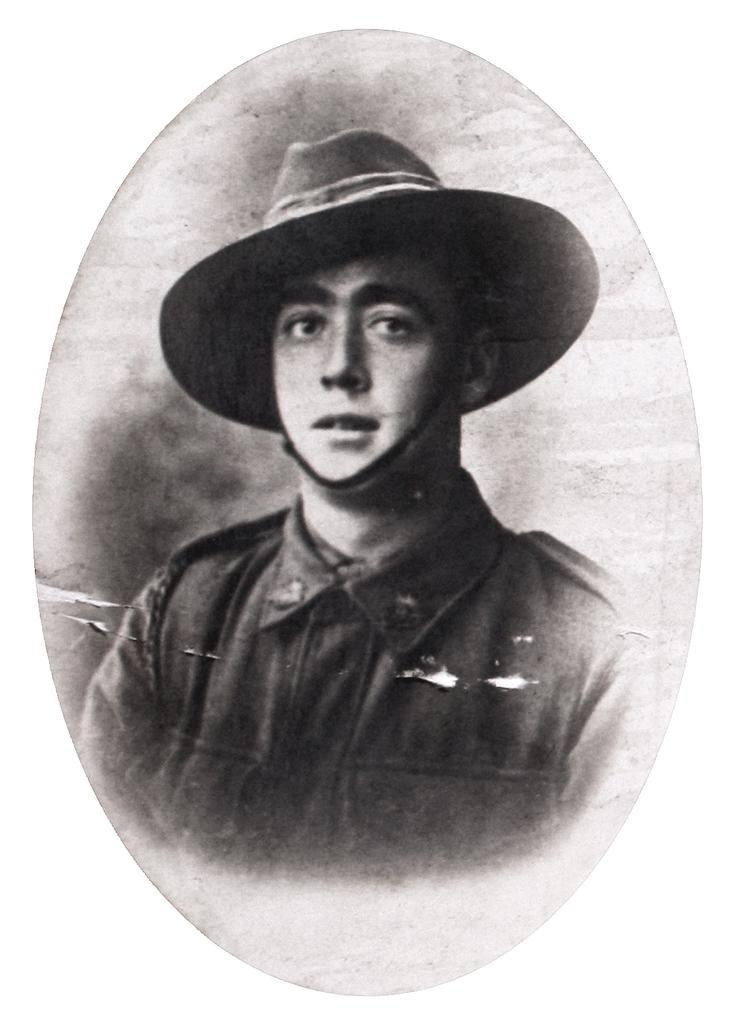What is the main subject of the image? There is a person in the image. What is the person wearing on their head? The person is wearing a hat. What is the color scheme of the image? The image is in black and white. What type of soup is being served in the image? There is no soup present in the image; it features a person wearing a hat in a black and white image. What is the person doing to slow down the vehicle in the image? There is no vehicle or brake present in the image; it only features a person wearing a hat in a black and white image. 